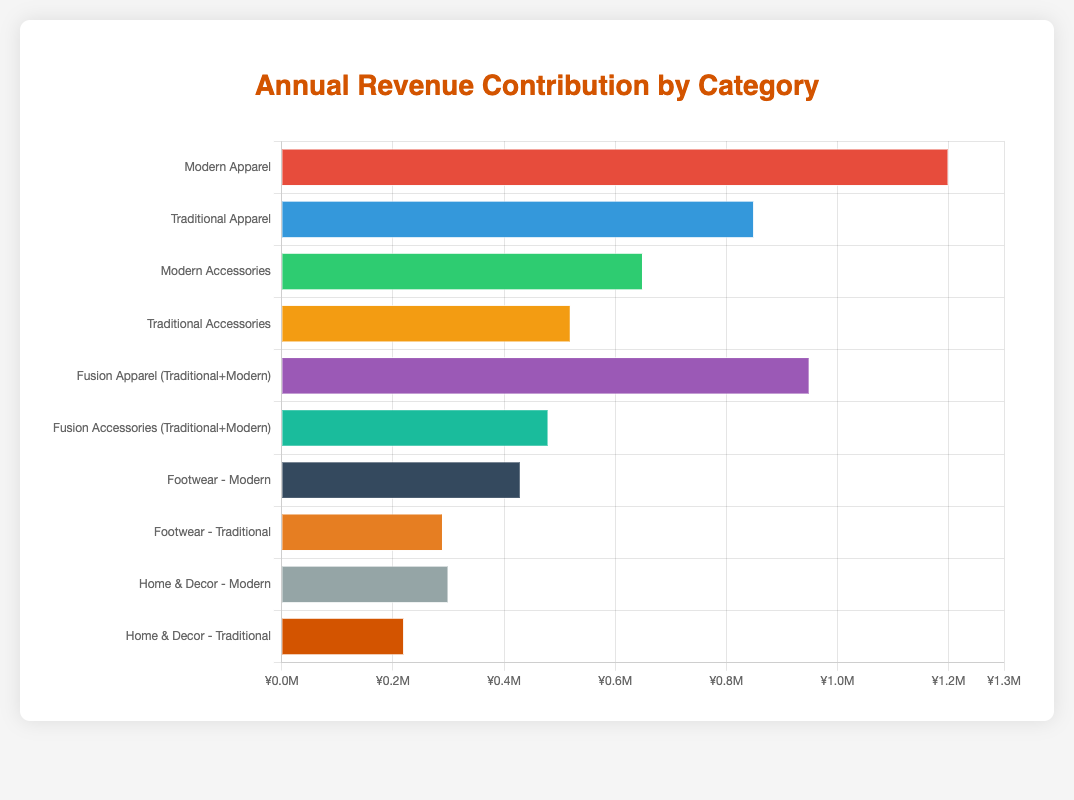Which product category contributes the highest annual revenue? The figure shows the revenue of each category on a horizontal bar chart. The bar representing "Modern Apparel" is the longest one, indicating it has the highest annual revenue.
Answer: Modern Apparel Which product category has the lowest annual revenue? By examining the length of the bars, "Home & Decor - Traditional" has the shortest bar, indicating it contributes the lowest annual revenue.
Answer: Home & Decor - Traditional What is the combined revenue of Modern Accessories and Traditional Accessories? Modern Accessories has a revenue of ¥0.65 million and Traditional Accessories has ¥0.52 million. Adding them together: 0.65 + 0.52 = 1.17 million.
Answer: 1.17 million Which category, Fusion Apparel (Traditional+Modern) or Traditional Apparel, contributes more revenue? By comparing the lengths of the bars, "Fusion Apparel (Traditional+Modern)" has a longer bar at ¥0.95 million, while "Traditional Apparel" has ¥0.85 million. Therefore, "Fusion Apparel (Traditional+Modern)" contributes more.
Answer: Fusion Apparel (Traditional+Modern) How much more revenue does Modern Apparel generate compared to Footwear - Traditional? Modern Apparel generates ¥1.2 million and Footwear - Traditional generates ¥0.29 million. The difference is 1.2 - 0.29 = 0.91 million.
Answer: 0.91 million Which categories have a revenue contribution higher than ¥0.5 million? Checking each bar visually, the categories with revenues higher than ¥0.5 million are: Modern Apparel, Traditional Apparel, Modern Accessories, Fusion Apparel (Traditional+Modern).
Answer: Modern Apparel, Traditional Apparel, Modern Accessories, Fusion Apparel (Traditional+Modern) How does the revenue of Home & Decor - Modern compare to that of Home & Decor - Traditional? Home & Decor - Modern has a revenue of ¥0.3 million, whereas Home & Decor - Traditional has ¥0.22 million. The former is greater.
Answer: Home & Decor - Modern is greater Which three categories have the highest revenue contributions? From the figure, the three longest bars, representing the highest revenue contributions, belong to: Modern Apparel, Fusion Apparel (Traditional+Modern), and Traditional Apparel.
Answer: Modern Apparel, Fusion Apparel (Traditional+Modern), Traditional Apparel What is the total revenue of all categories related to footwear? Summing the revenues of "Footwear - Modern" (¥0.43 million) and "Footwear - Traditional" (¥0.29 million): 0.43 + 0.29 = 0.72 million.
Answer: 0.72 million Is the revenue of Fusion Accessories (Traditional+Modern) closer to Modern Accessories or Traditional Accessories? Fusion Accessories (Traditional+Modern) has a revenue of ¥0.48 million. Modern Accessories has ¥0.65 million and Traditional Accessories has ¥0.52 million. The difference with Modern Accessories is 0.65 - 0.48 = 0.17 and with Traditional Accessories is 0.52 - 0.48 = 0.04. The revenue is closer to Traditional Accessories.
Answer: Traditional Accessories 